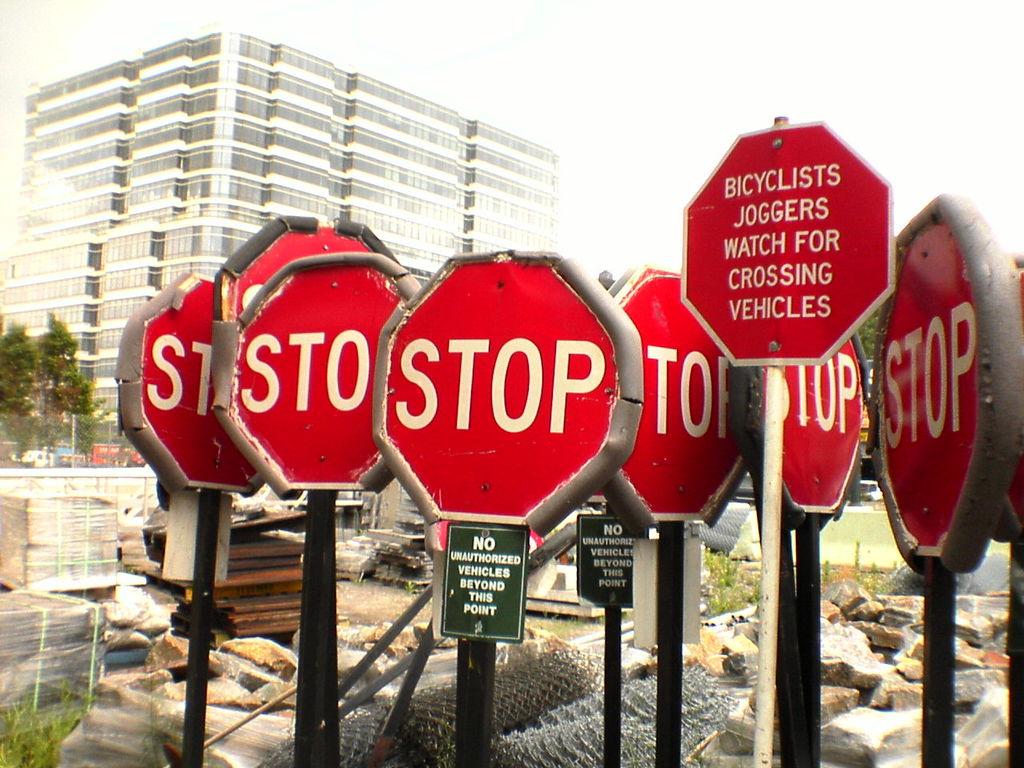What do we need to watch for?
Offer a terse response. Crossing vehicles. What are prohibited beyond this point?
Keep it short and to the point. Unauthorized vehicles. 